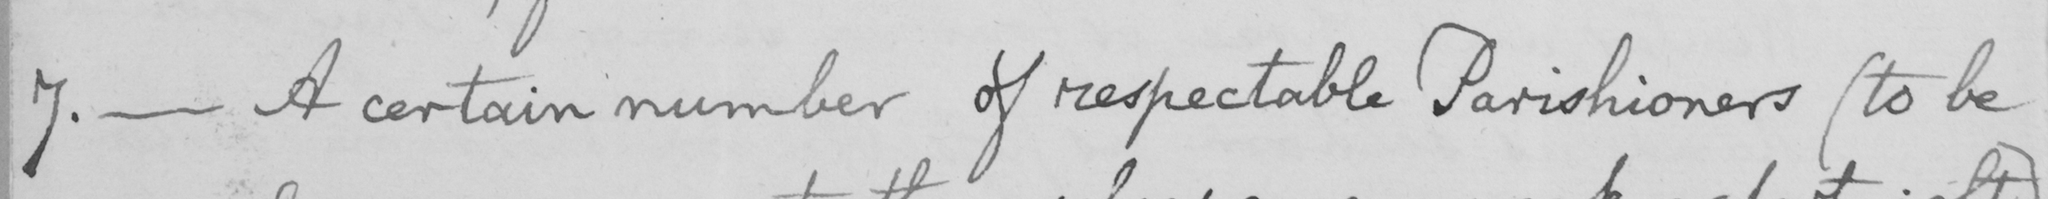What text is written in this handwritten line? 7 .  _  A certain number of respectable Parishioners  ( to be 